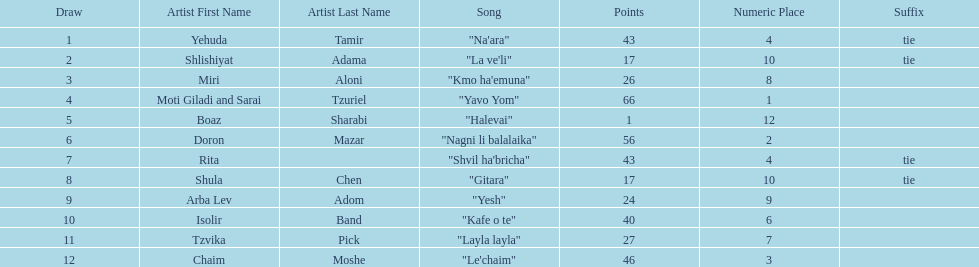What are the points? 43, 17, 26, 66, 1, 56, 43, 17, 24, 40, 27, 46. What is the least? 1. Would you mind parsing the complete table? {'header': ['Draw', 'Artist First Name', 'Artist Last Name', 'Song', 'Points', 'Numeric Place', 'Suffix'], 'rows': [['1', 'Yehuda', 'Tamir', '"Na\'ara"', '43', '4', 'tie'], ['2', 'Shlishiyat', 'Adama', '"La ve\'li"', '17', '10', 'tie'], ['3', 'Miri', 'Aloni', '"Kmo ha\'emuna"', '26', '8', ''], ['4', 'Moti Giladi and Sarai', 'Tzuriel', '"Yavo Yom"', '66', '1', ''], ['5', 'Boaz', 'Sharabi', '"Halevai"', '1', '12', ''], ['6', 'Doron', 'Mazar', '"Nagni li balalaika"', '56', '2', ''], ['7', 'Rita', '', '"Shvil ha\'bricha"', '43', '4', 'tie'], ['8', 'Shula', 'Chen', '"Gitara"', '17', '10', 'tie'], ['9', 'Arba Lev', 'Adom', '"Yesh"', '24', '9', ''], ['10', 'Isolir', 'Band', '"Kafe o te"', '40', '6', ''], ['11', 'Tzvika', 'Pick', '"Layla layla"', '27', '7', ''], ['12', 'Chaim', 'Moshe', '"Le\'chaim"', '46', '3', '']]} Which artist has that much Boaz Sharabi. 